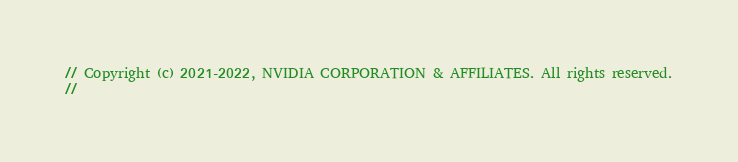<code> <loc_0><loc_0><loc_500><loc_500><_Cuda_>// Copyright (c) 2021-2022, NVIDIA CORPORATION & AFFILIATES. All rights reserved.
//</code> 